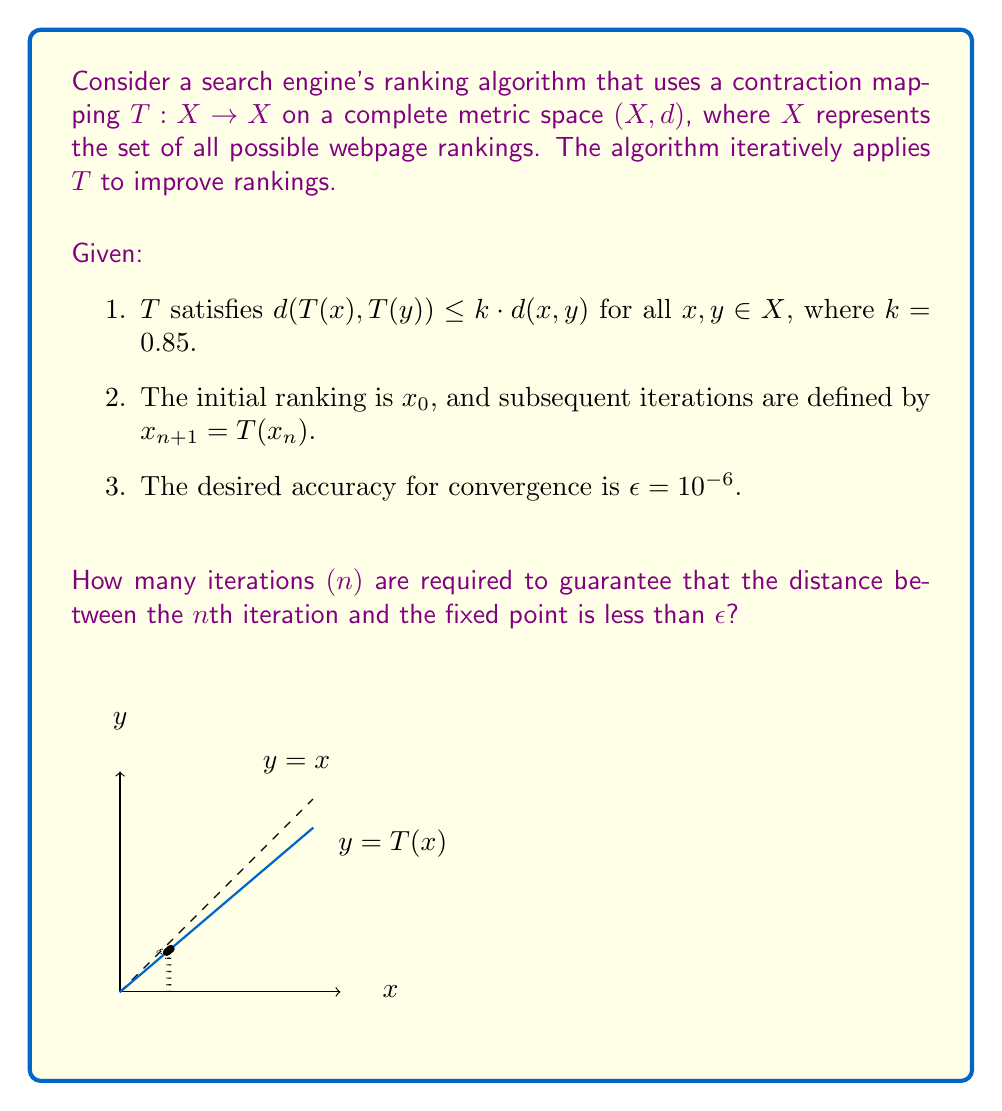Give your solution to this math problem. To solve this problem, we'll use the Banach fixed-point theorem and properties of contraction mappings:

1) The Banach fixed-point theorem guarantees that $T$ has a unique fixed point $x^*$ in $X$.

2) For a contraction mapping, we have the inequality:
   $$d(x_n, x^*) \leq \frac{k^n}{1-k} d(x_1, x_0)$$

3) We want to find $n$ such that:
   $$\frac{k^n}{1-k} d(x_1, x_0) < \epsilon$$

4) We don't know $d(x_1, x_0)$, but we can use the worst-case scenario where $d(x_1, x_0) = \text{diam}(X)$, the diameter of $X$. Let's assume $\text{diam}(X) = 1$ for simplicity.

5) Substituting the known values:
   $$\frac{0.85^n}{1-0.85} \cdot 1 < 10^{-6}$$

6) Simplifying:
   $$0.85^n < 10^{-6} \cdot 0.15 = 1.5 \cdot 10^{-7}$$

7) Taking logarithms of both sides:
   $$n \cdot \log(0.85) < \log(1.5 \cdot 10^{-7})$$

8) Solving for $n$:
   $$n > \frac{\log(1.5 \cdot 10^{-7})}{\log(0.85)} \approx 101.68$$

9) Since $n$ must be an integer, we round up to the next whole number.

Therefore, 102 iterations are required to guarantee the desired accuracy.
Answer: 102 iterations 